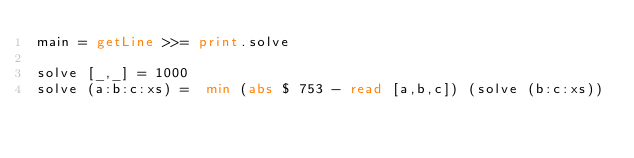<code> <loc_0><loc_0><loc_500><loc_500><_Haskell_>main = getLine >>= print.solve

solve [_,_] = 1000
solve (a:b:c:xs) =  min (abs $ 753 - read [a,b,c]) (solve (b:c:xs))</code> 